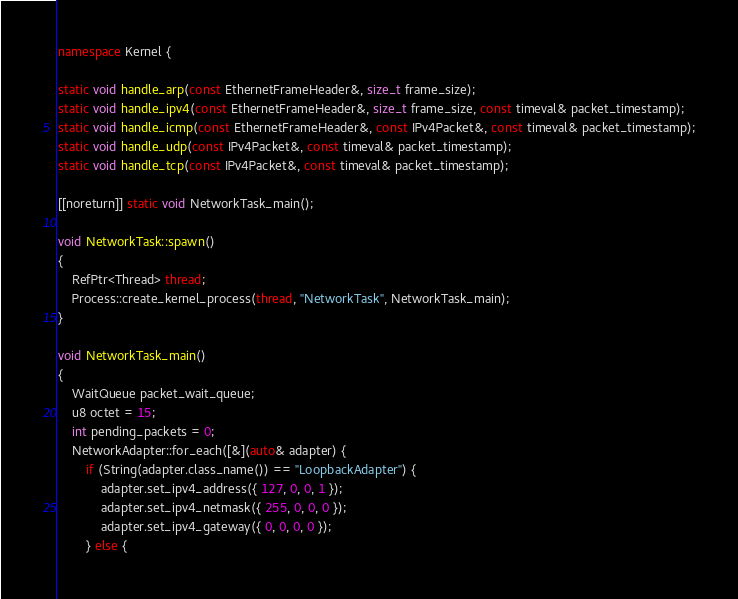<code> <loc_0><loc_0><loc_500><loc_500><_C++_>
namespace Kernel {

static void handle_arp(const EthernetFrameHeader&, size_t frame_size);
static void handle_ipv4(const EthernetFrameHeader&, size_t frame_size, const timeval& packet_timestamp);
static void handle_icmp(const EthernetFrameHeader&, const IPv4Packet&, const timeval& packet_timestamp);
static void handle_udp(const IPv4Packet&, const timeval& packet_timestamp);
static void handle_tcp(const IPv4Packet&, const timeval& packet_timestamp);

[[noreturn]] static void NetworkTask_main();

void NetworkTask::spawn()
{
    RefPtr<Thread> thread;
    Process::create_kernel_process(thread, "NetworkTask", NetworkTask_main);
}

void NetworkTask_main()
{
    WaitQueue packet_wait_queue;
    u8 octet = 15;
    int pending_packets = 0;
    NetworkAdapter::for_each([&](auto& adapter) {
        if (String(adapter.class_name()) == "LoopbackAdapter") {
            adapter.set_ipv4_address({ 127, 0, 0, 1 });
            adapter.set_ipv4_netmask({ 255, 0, 0, 0 });
            adapter.set_ipv4_gateway({ 0, 0, 0, 0 });
        } else {</code> 